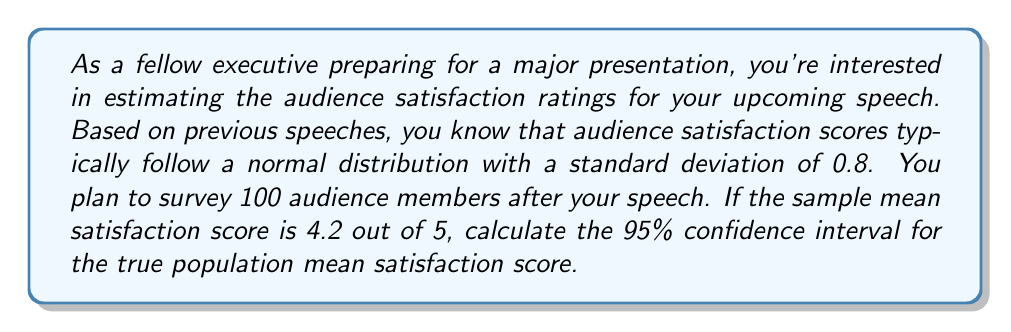Provide a solution to this math problem. Let's approach this step-by-step:

1) We're dealing with a confidence interval for a population mean where the population standard deviation is known. This calls for the use of the z-interval formula.

2) The formula for a confidence interval is:

   $$\bar{x} \pm z_{\alpha/2} \cdot \frac{\sigma}{\sqrt{n}}$$

   Where:
   - $\bar{x}$ is the sample mean
   - $z_{\alpha/2}$ is the critical value for the desired confidence level
   - $\sigma$ is the population standard deviation
   - $n$ is the sample size

3) We're given:
   - $\bar{x} = 4.2$
   - $\sigma = 0.8$
   - $n = 100$
   - Confidence level = 95%

4) For a 95% confidence interval, $\alpha = 0.05$, and $z_{\alpha/2} = 1.96$

5) Plugging these values into our formula:

   $$4.2 \pm 1.96 \cdot \frac{0.8}{\sqrt{100}}$$

6) Simplify:
   $$4.2 \pm 1.96 \cdot \frac{0.8}{10} = 4.2 \pm 1.96 \cdot 0.08 = 4.2 \pm 0.1568$$

7) Calculate the interval:
   $$4.2 - 0.1568 = 4.0432$$
   $$4.2 + 0.1568 = 4.3568$$

Therefore, we can be 95% confident that the true population mean satisfaction score falls between 4.0432 and 4.3568.
Answer: The 95% confidence interval for the true population mean satisfaction score is (4.0432, 4.3568). 